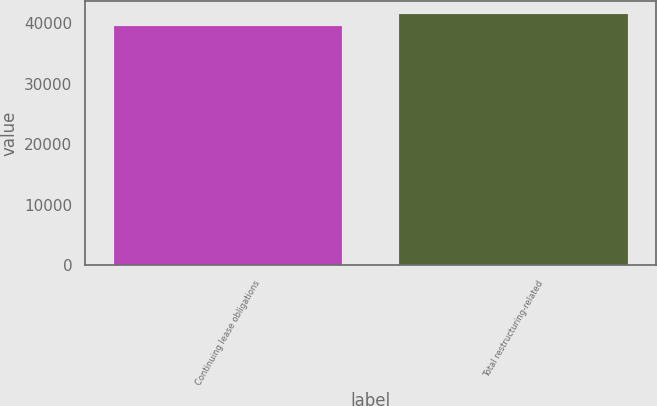<chart> <loc_0><loc_0><loc_500><loc_500><bar_chart><fcel>Continuing lease obligations<fcel>Total restructuring-related<nl><fcel>39563<fcel>41573<nl></chart> 